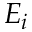<formula> <loc_0><loc_0><loc_500><loc_500>E _ { i }</formula> 